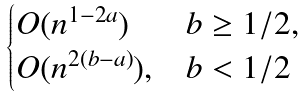<formula> <loc_0><loc_0><loc_500><loc_500>\begin{cases} O ( n ^ { 1 - 2 a } ) & b \geq 1 / 2 , \\ O ( n ^ { 2 ( b - a ) } ) , & b < 1 / 2 \end{cases}</formula> 